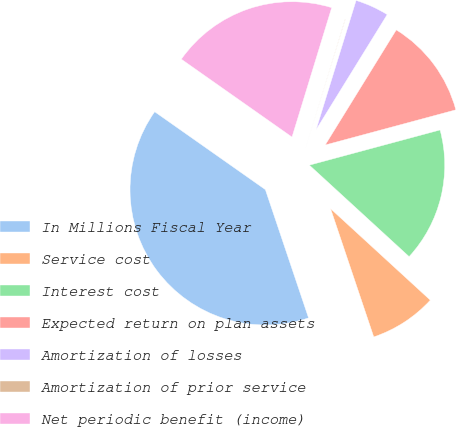<chart> <loc_0><loc_0><loc_500><loc_500><pie_chart><fcel>In Millions Fiscal Year<fcel>Service cost<fcel>Interest cost<fcel>Expected return on plan assets<fcel>Amortization of losses<fcel>Amortization of prior service<fcel>Net periodic benefit (income)<nl><fcel>39.93%<fcel>8.02%<fcel>16.0%<fcel>12.01%<fcel>4.03%<fcel>0.04%<fcel>19.98%<nl></chart> 